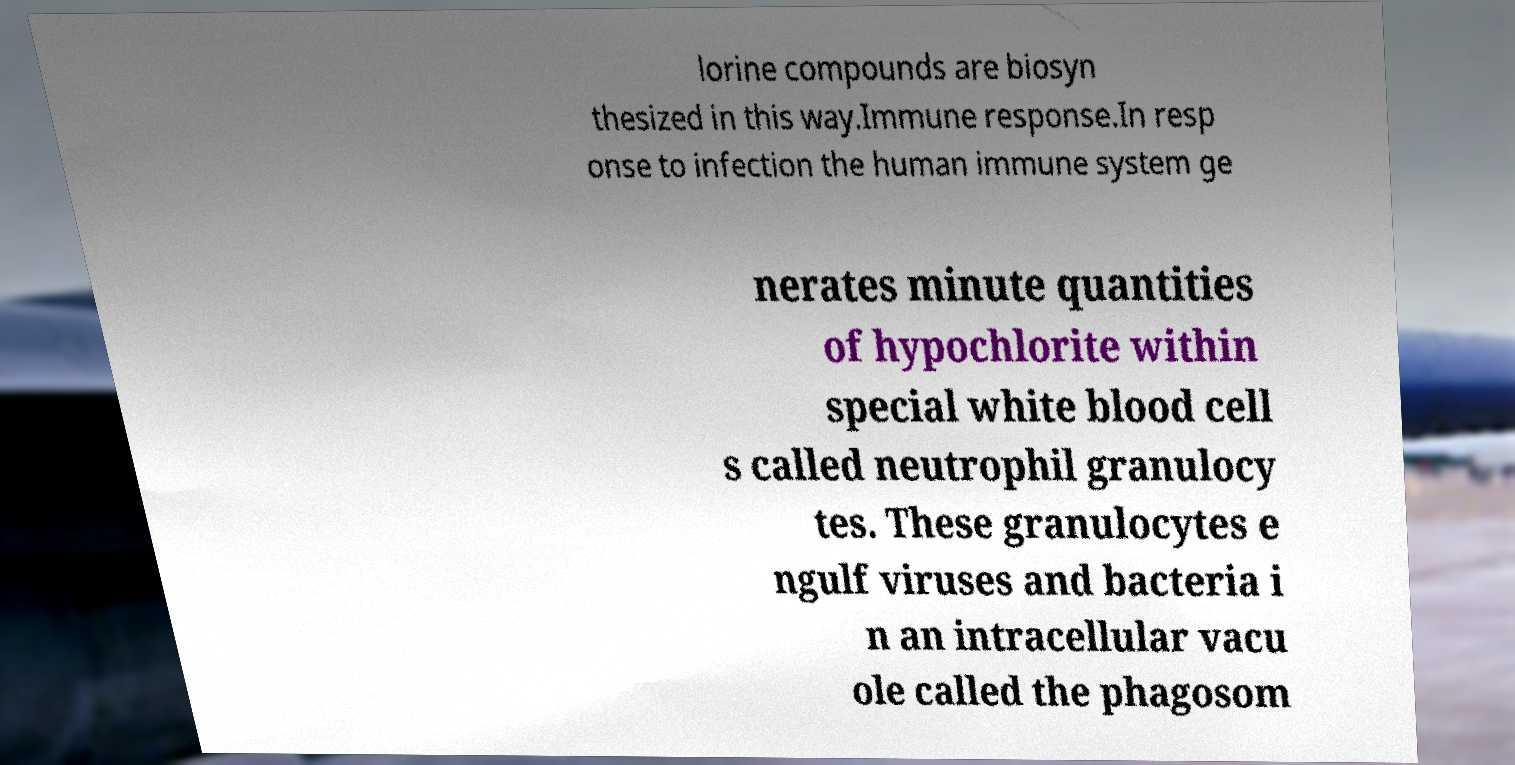Can you read and provide the text displayed in the image?This photo seems to have some interesting text. Can you extract and type it out for me? lorine compounds are biosyn thesized in this way.Immune response.In resp onse to infection the human immune system ge nerates minute quantities of hypochlorite within special white blood cell s called neutrophil granulocy tes. These granulocytes e ngulf viruses and bacteria i n an intracellular vacu ole called the phagosom 